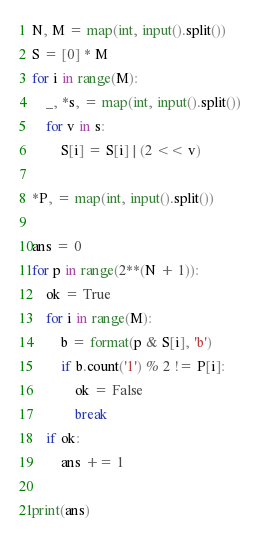<code> <loc_0><loc_0><loc_500><loc_500><_Python_>N, M = map(int, input().split())
S = [0] * M
for i in range(M):
    _, *s, = map(int, input().split())
    for v in s:
        S[i] = S[i] | (2 << v)

*P, = map(int, input().split())

ans = 0
for p in range(2**(N + 1)):
    ok = True
    for i in range(M):
        b = format(p & S[i], 'b')
        if b.count('1') % 2 != P[i]:
            ok = False
            break
    if ok:
        ans += 1

print(ans)</code> 